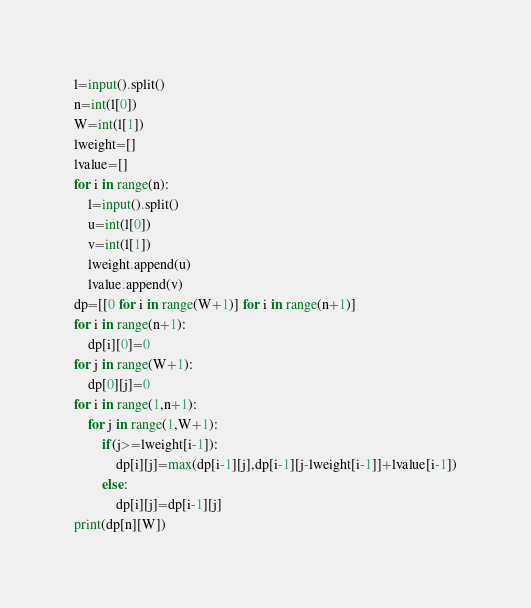Convert code to text. <code><loc_0><loc_0><loc_500><loc_500><_Python_>l=input().split()
n=int(l[0])
W=int(l[1])
lweight=[]
lvalue=[]
for i in range(n):
	l=input().split()
	u=int(l[0])
	v=int(l[1])
	lweight.append(u)
	lvalue.append(v)
dp=[[0 for i in range(W+1)] for i in range(n+1)]
for i in range(n+1):
	dp[i][0]=0
for j in range(W+1):
	dp[0][j]=0
for i in range(1,n+1):
	for j in range(1,W+1):
		if(j>=lweight[i-1]):
			dp[i][j]=max(dp[i-1][j],dp[i-1][j-lweight[i-1]]+lvalue[i-1])
		else:
			dp[i][j]=dp[i-1][j]
print(dp[n][W])
</code> 